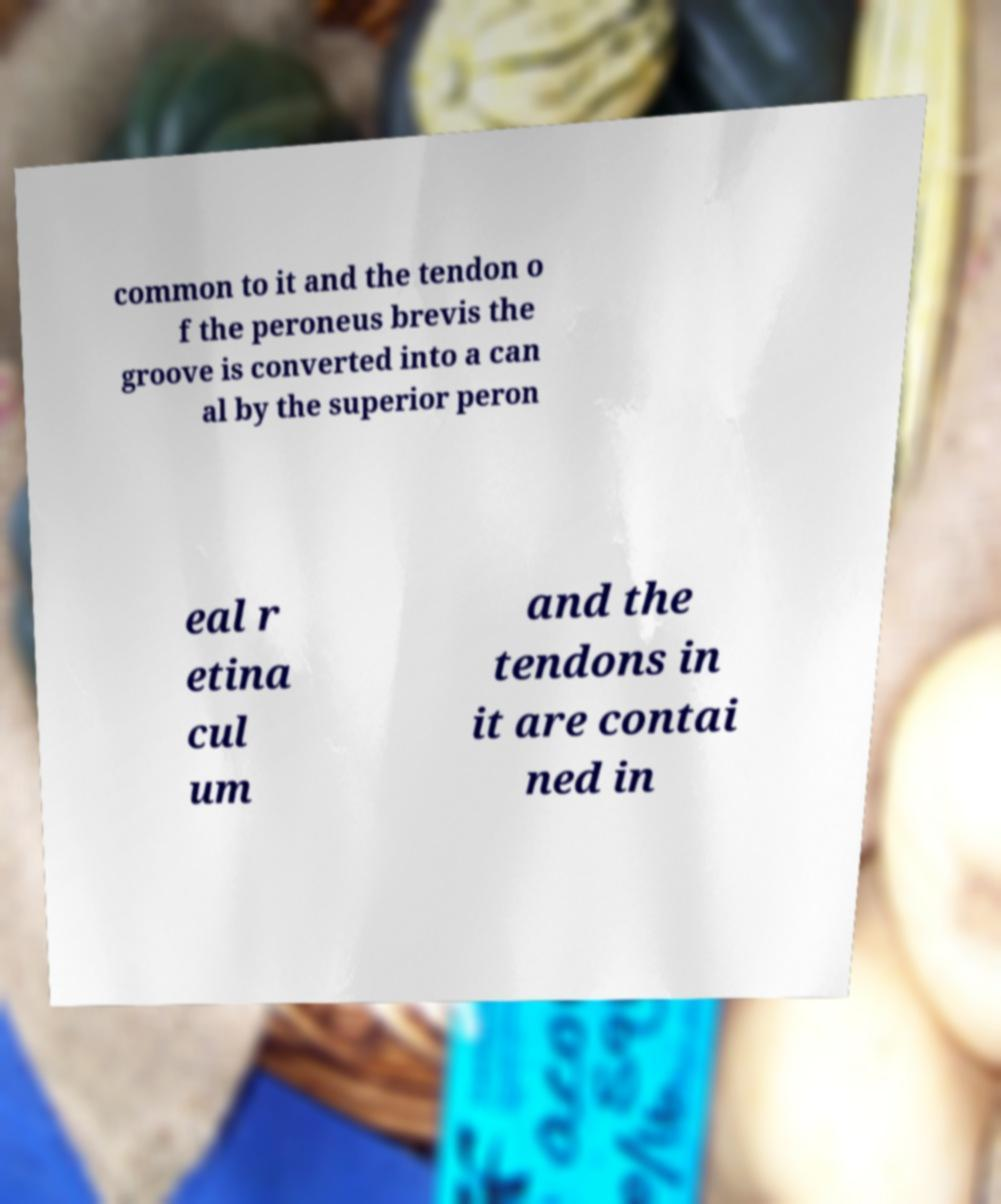Can you accurately transcribe the text from the provided image for me? common to it and the tendon o f the peroneus brevis the groove is converted into a can al by the superior peron eal r etina cul um and the tendons in it are contai ned in 